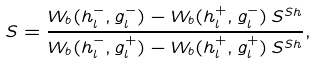Convert formula to latex. <formula><loc_0><loc_0><loc_500><loc_500>S = \frac { W _ { b } ( h ^ { - } _ { l } , g ^ { - } _ { l } ) - W _ { b } ( h ^ { + } _ { l } , g ^ { - } _ { l } ) \, S ^ { S h } } { W _ { b } ( h ^ { - } _ { l } , g ^ { + } _ { l } ) - W _ { b } ( h ^ { + } _ { l } , g ^ { + } _ { l } ) \, S ^ { S h } } ,</formula> 